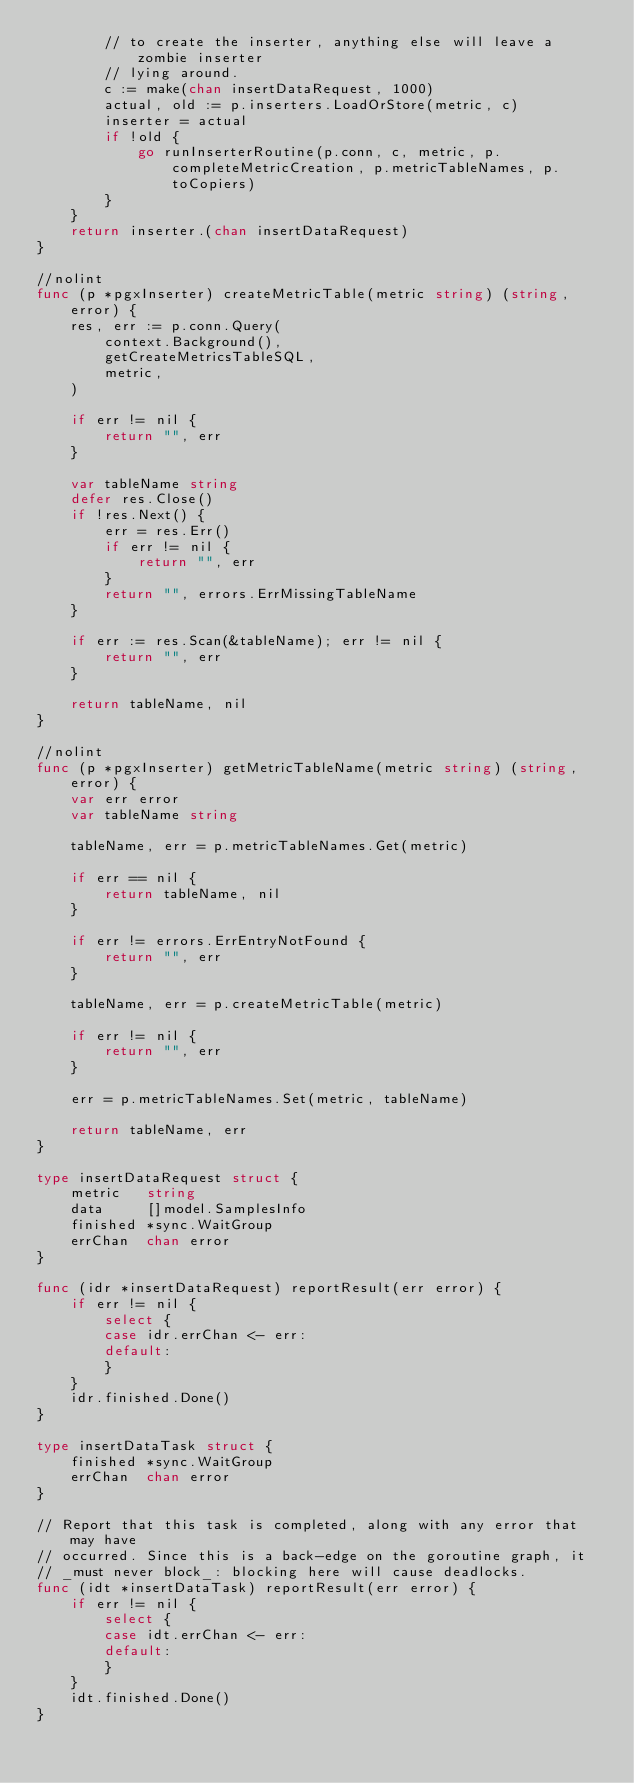Convert code to text. <code><loc_0><loc_0><loc_500><loc_500><_Go_>		// to create the inserter, anything else will leave a zombie inserter
		// lying around.
		c := make(chan insertDataRequest, 1000)
		actual, old := p.inserters.LoadOrStore(metric, c)
		inserter = actual
		if !old {
			go runInserterRoutine(p.conn, c, metric, p.completeMetricCreation, p.metricTableNames, p.toCopiers)
		}
	}
	return inserter.(chan insertDataRequest)
}

//nolint
func (p *pgxInserter) createMetricTable(metric string) (string, error) {
	res, err := p.conn.Query(
		context.Background(),
		getCreateMetricsTableSQL,
		metric,
	)

	if err != nil {
		return "", err
	}

	var tableName string
	defer res.Close()
	if !res.Next() {
		err = res.Err()
		if err != nil {
			return "", err
		}
		return "", errors.ErrMissingTableName
	}

	if err := res.Scan(&tableName); err != nil {
		return "", err
	}

	return tableName, nil
}

//nolint
func (p *pgxInserter) getMetricTableName(metric string) (string, error) {
	var err error
	var tableName string

	tableName, err = p.metricTableNames.Get(metric)

	if err == nil {
		return tableName, nil
	}

	if err != errors.ErrEntryNotFound {
		return "", err
	}

	tableName, err = p.createMetricTable(metric)

	if err != nil {
		return "", err
	}

	err = p.metricTableNames.Set(metric, tableName)

	return tableName, err
}

type insertDataRequest struct {
	metric   string
	data     []model.SamplesInfo
	finished *sync.WaitGroup
	errChan  chan error
}

func (idr *insertDataRequest) reportResult(err error) {
	if err != nil {
		select {
		case idr.errChan <- err:
		default:
		}
	}
	idr.finished.Done()
}

type insertDataTask struct {
	finished *sync.WaitGroup
	errChan  chan error
}

// Report that this task is completed, along with any error that may have
// occurred. Since this is a back-edge on the goroutine graph, it
// _must never block_: blocking here will cause deadlocks.
func (idt *insertDataTask) reportResult(err error) {
	if err != nil {
		select {
		case idt.errChan <- err:
		default:
		}
	}
	idt.finished.Done()
}
</code> 